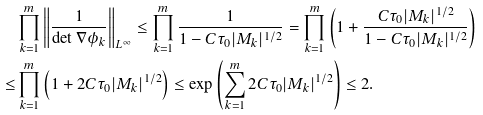Convert formula to latex. <formula><loc_0><loc_0><loc_500><loc_500>& \prod _ { k = 1 } ^ { m } \left \| \frac { 1 } { \det \nabla \phi _ { k } } \right \| _ { L ^ { \infty } } \leq \prod _ { k = 1 } ^ { m } \frac { 1 } { 1 - C \tau _ { 0 } | M _ { k } | ^ { 1 / 2 } } = \prod _ { k = 1 } ^ { m } \left ( 1 + \frac { C \tau _ { 0 } | M _ { k } | ^ { 1 / 2 } } { 1 - C \tau _ { 0 } | M _ { k } | ^ { 1 / 2 } } \right ) \\ \leq & \prod _ { k = 1 } ^ { m } \left ( 1 + 2 C \tau _ { 0 } | M _ { k } | ^ { 1 / 2 } \right ) \leq \exp \left ( \sum _ { k = 1 } ^ { m } 2 C \tau _ { 0 } | M _ { k } | ^ { 1 / 2 } \right ) \leq 2 .</formula> 